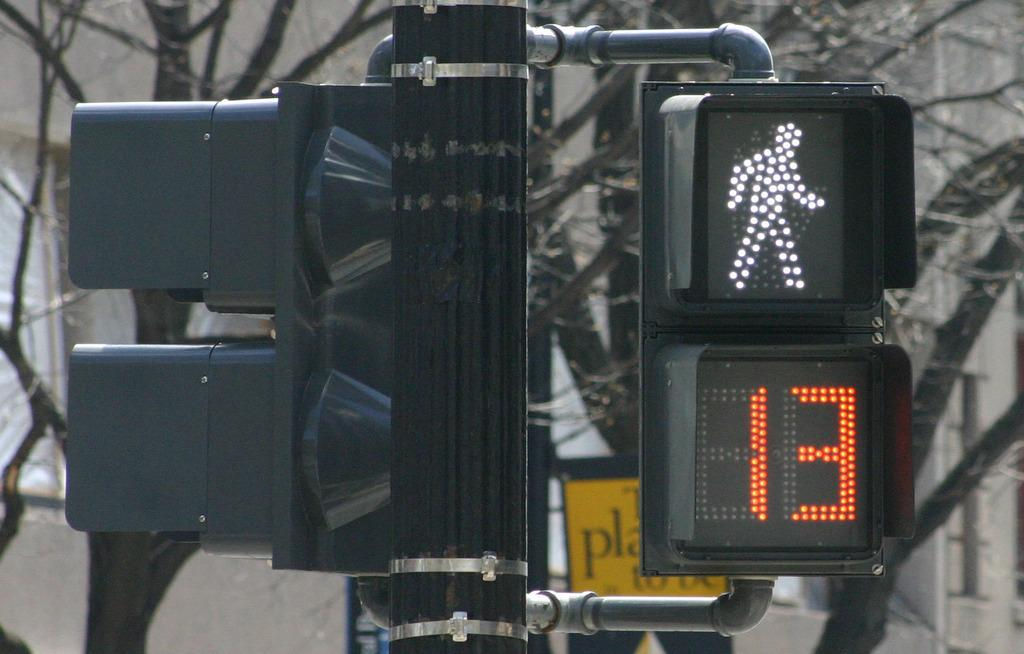<image>
Describe the image concisely. a street sign and walking sign is on for the next 13 seconds 